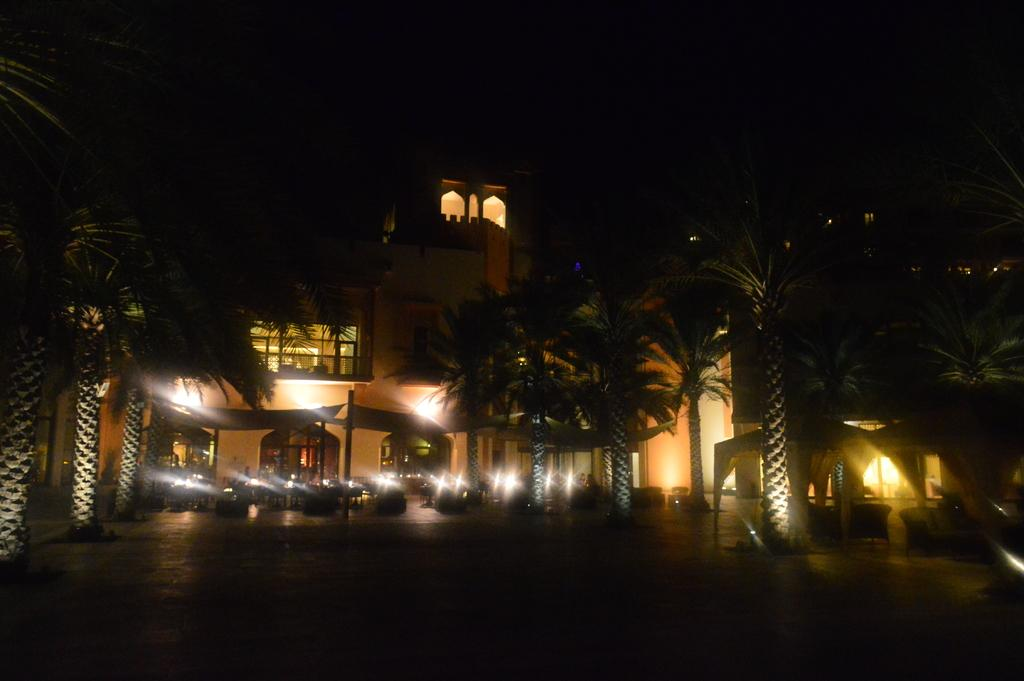What type of furniture is present in the image? There are tables and chairs in the image. Where are the tables and chairs located? The tables and chairs are under tents. What can be seen in the background of the image? There are trees and a building visible in the background of the image. What is the process of digestion for the doll in the image? There is no doll present in the image, so the process of digestion cannot be discussed. 